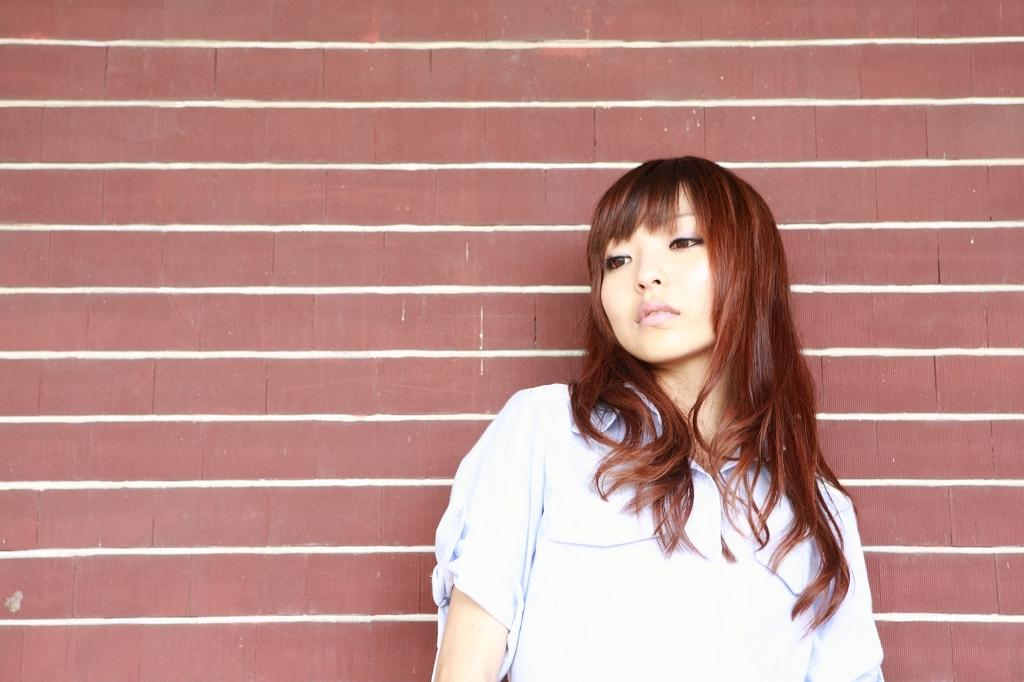Who is present in the image? There is a woman in the image. What is the woman wearing? The woman is wearing a shirt. What can be seen in the background of the image? There is a wall visible in the background of the image. What type of cord is being used by the woman in the image? There is no cord visible in the image; the woman is simply standing and wearing a shirt. 